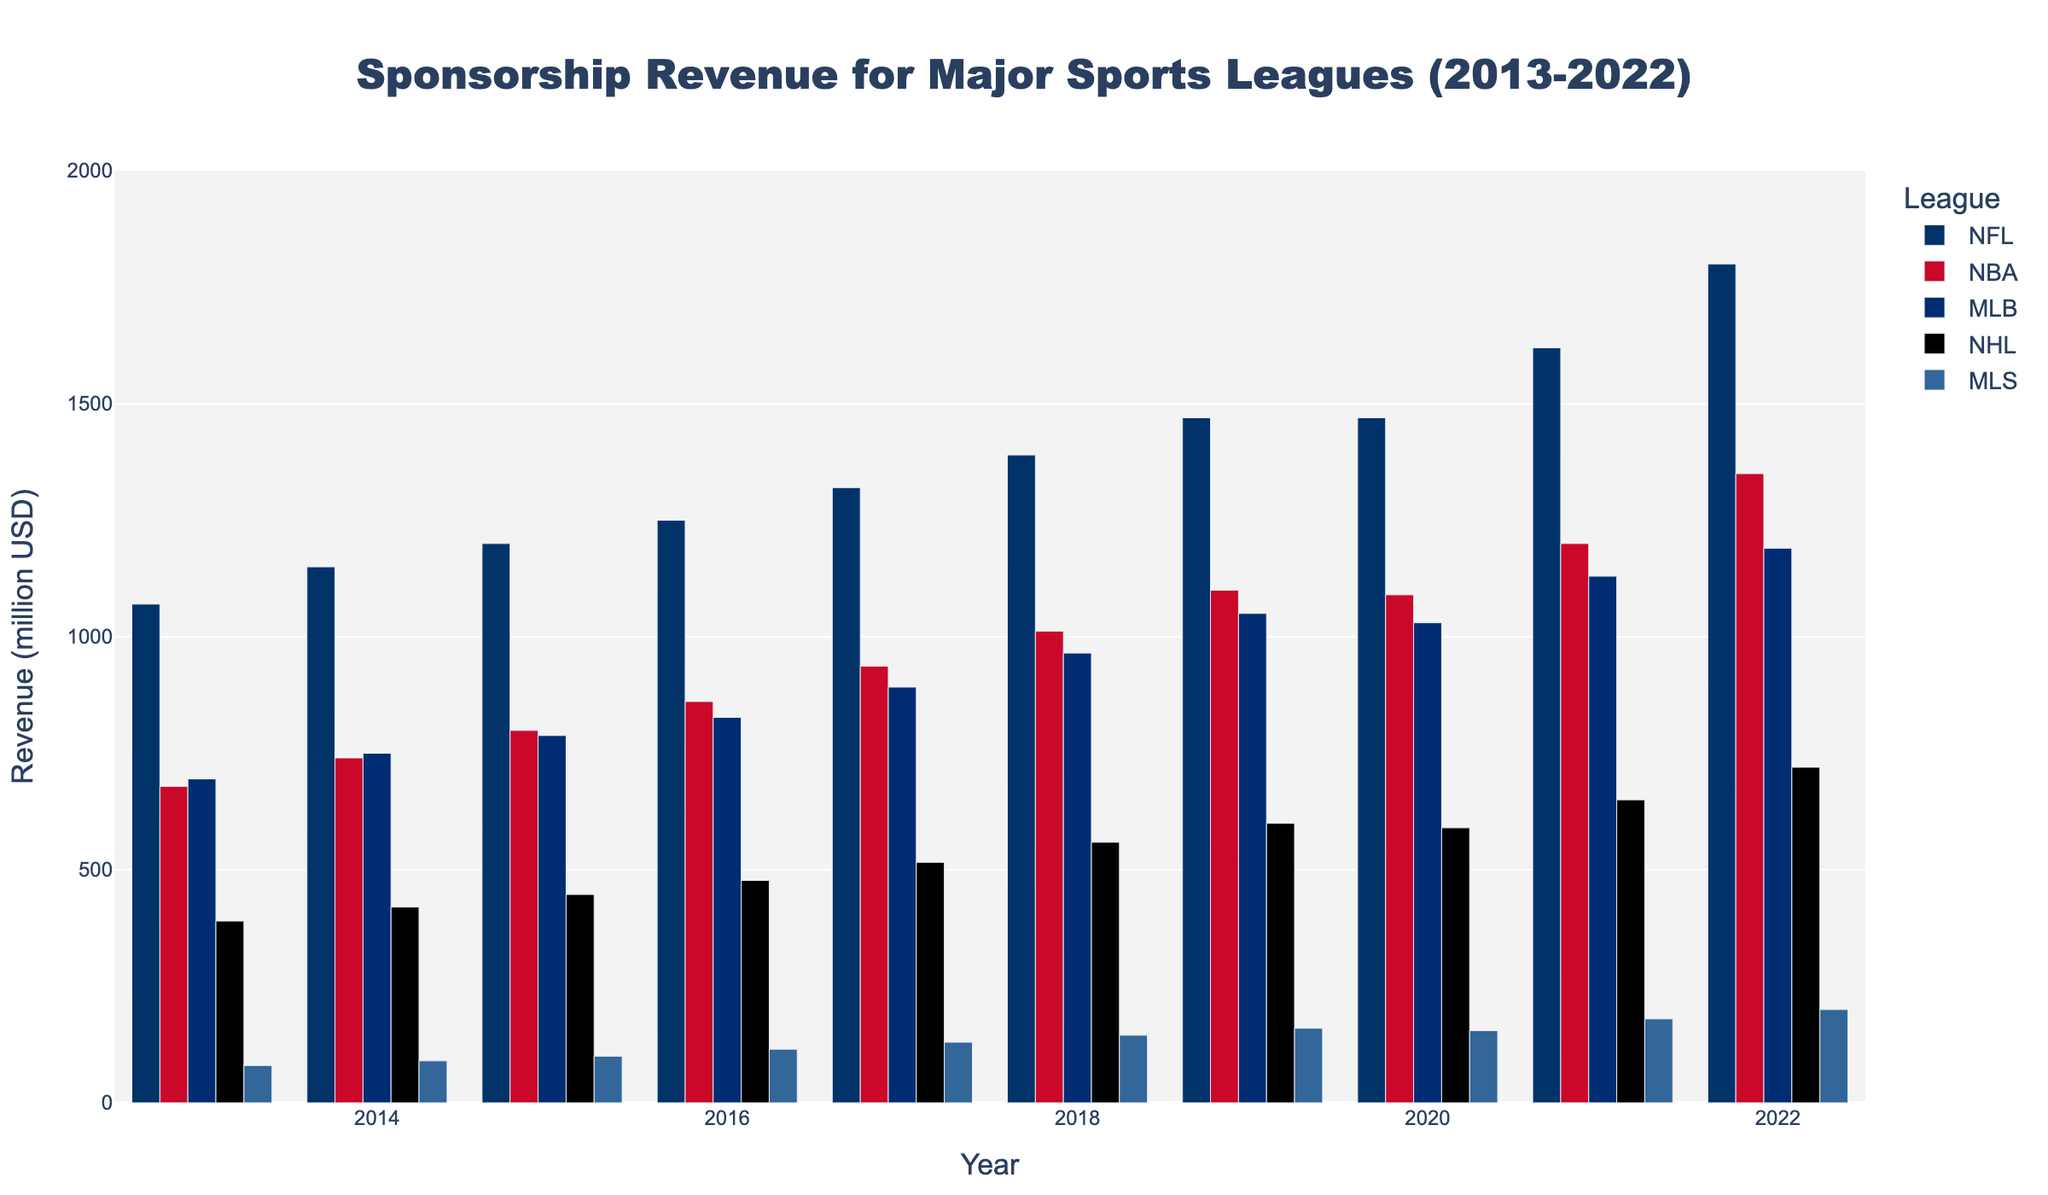Which league had the highest sponsorship revenue in 2022? By looking at the bar heights for each league in the year 2022, the NFL has the tallest bar indicating it had the highest sponsorship revenue.
Answer: NFL How much more sponsorship revenue did the NFL generate compared to the NHL in 2022? The NFL's revenue in 2022 is 1800 million USD, and the NHL's revenue is 720 million USD. The difference is calculated as 1800 - 720 = 1080 million USD.
Answer: 1080 million USD Which league had the lowest growth in sponsorship revenue from 2013 to 2022? By comparing the bars in 2013 and 2022 for each league, MLS shows the smallest difference (from 80 million USD in 2013 to 200 million USD in 2022, a growth of 120 million USD).
Answer: MLS What is the average sponsorship revenue of MLB from 2013 to 2022? Adding up MLB's revenues from each year: 695 + 750 + 788 + 827 + 892 + 965 + 1050 + 1030 + 1130 + 1190 = 9317 million USD. Divide by the number of years (10): 9317 / 10 = 931.7 million USD.
Answer: 931.7 million USD Did any league have a decrease in sponsorship revenue in any year? Observing the bars year over year, both the NBA and MLS show a slight decrease from 2019 to 2020. NBA from 1100 million USD to 1090 million USD and MLS from 160 million USD to 155 million USD.
Answer: Yes Which two leagues had the closest sponsorship revenue in 2021? By comparing the bars for 2021, MLB and NBA had revenues closest to each other with MLB at 1130 million USD and NBA at 1200 million USD.
Answer: MLB, NBA What is the overall trend in sponsorship revenue for the NFL from 2013 to 2022? Observing the bars for the NFL, there is a clear uptrend in sponsorship revenue from 1070 million USD in 2013 to 1800 million USD in 2022.
Answer: Increasing trend 